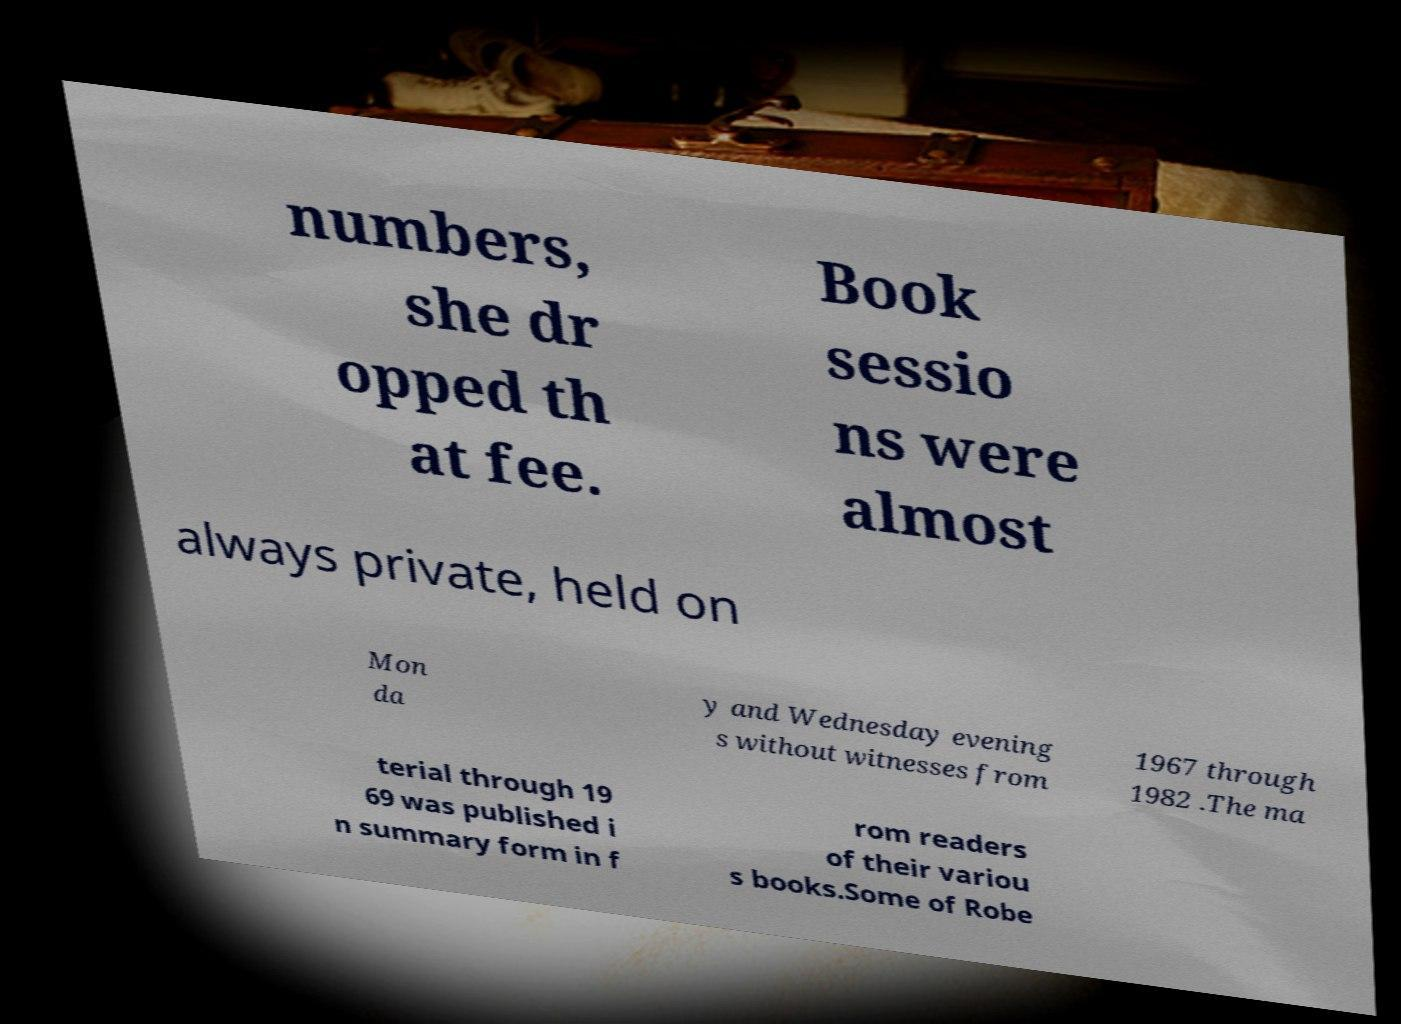Please identify and transcribe the text found in this image. numbers, she dr opped th at fee. Book sessio ns were almost always private, held on Mon da y and Wednesday evening s without witnesses from 1967 through 1982 .The ma terial through 19 69 was published i n summary form in f rom readers of their variou s books.Some of Robe 